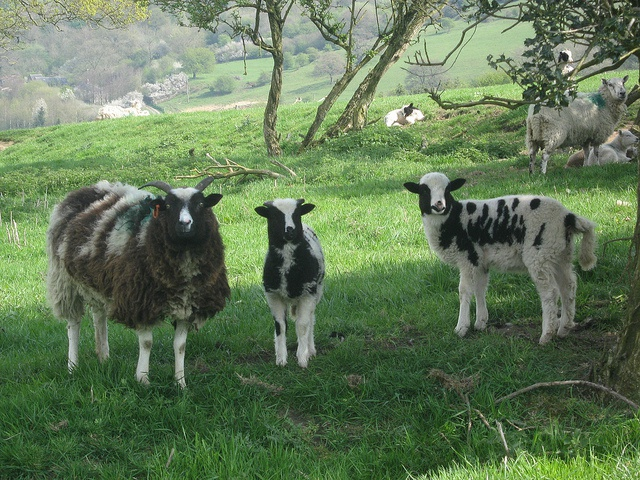Describe the objects in this image and their specific colors. I can see sheep in darkgray, black, gray, and darkgreen tones, sheep in darkgray, gray, and black tones, sheep in darkgray, black, and gray tones, sheep in darkgray, gray, and black tones, and sheep in darkgray, gray, and black tones in this image. 